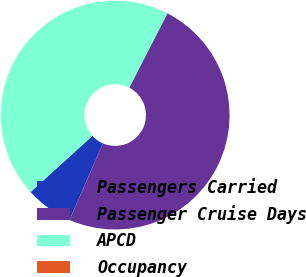Convert chart. <chart><loc_0><loc_0><loc_500><loc_500><pie_chart><fcel>Passengers Carried<fcel>Passenger Cruise Days<fcel>APCD<fcel>Occupancy<nl><fcel>6.73%<fcel>48.99%<fcel>44.28%<fcel>0.0%<nl></chart> 